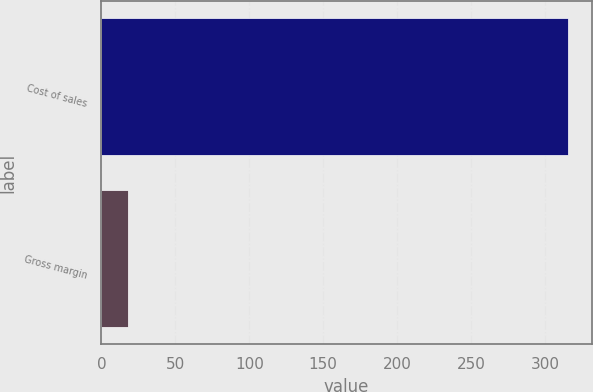Convert chart. <chart><loc_0><loc_0><loc_500><loc_500><bar_chart><fcel>Cost of sales<fcel>Gross margin<nl><fcel>316<fcel>18<nl></chart> 